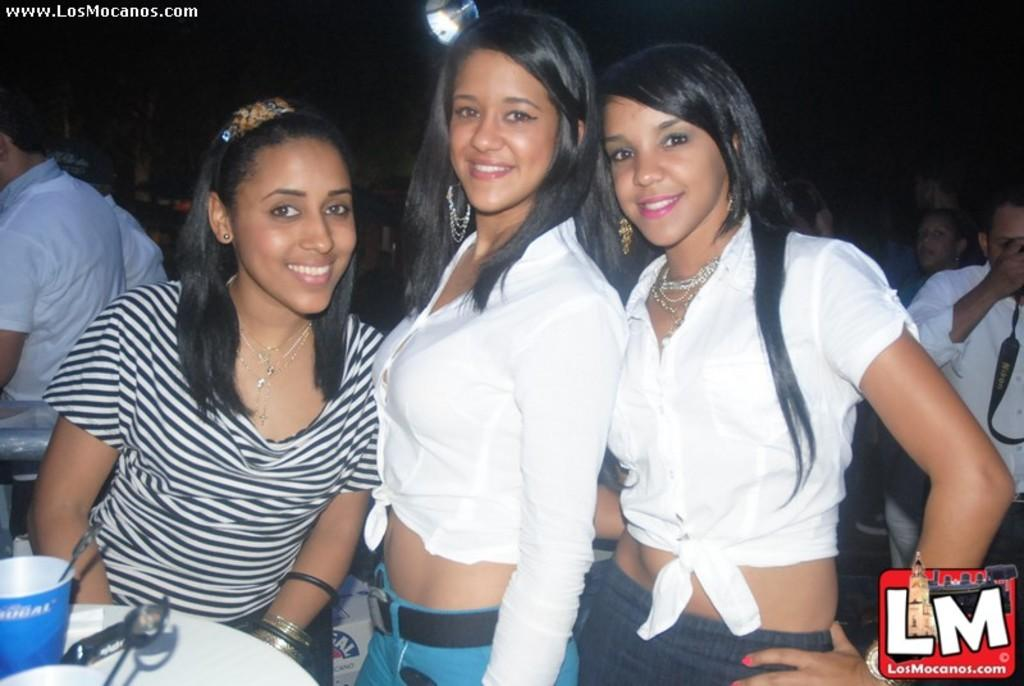<image>
Share a concise interpretation of the image provided. three girls taking a picture that says 'lm' on the bottom right 